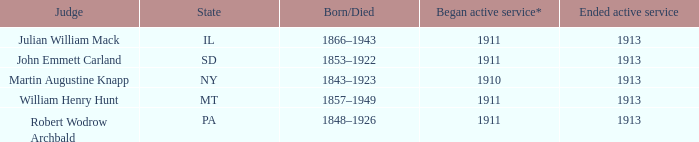Who was the judge for the state SD? John Emmett Carland. 